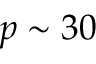Convert formula to latex. <formula><loc_0><loc_0><loc_500><loc_500>p \sim 3 0</formula> 